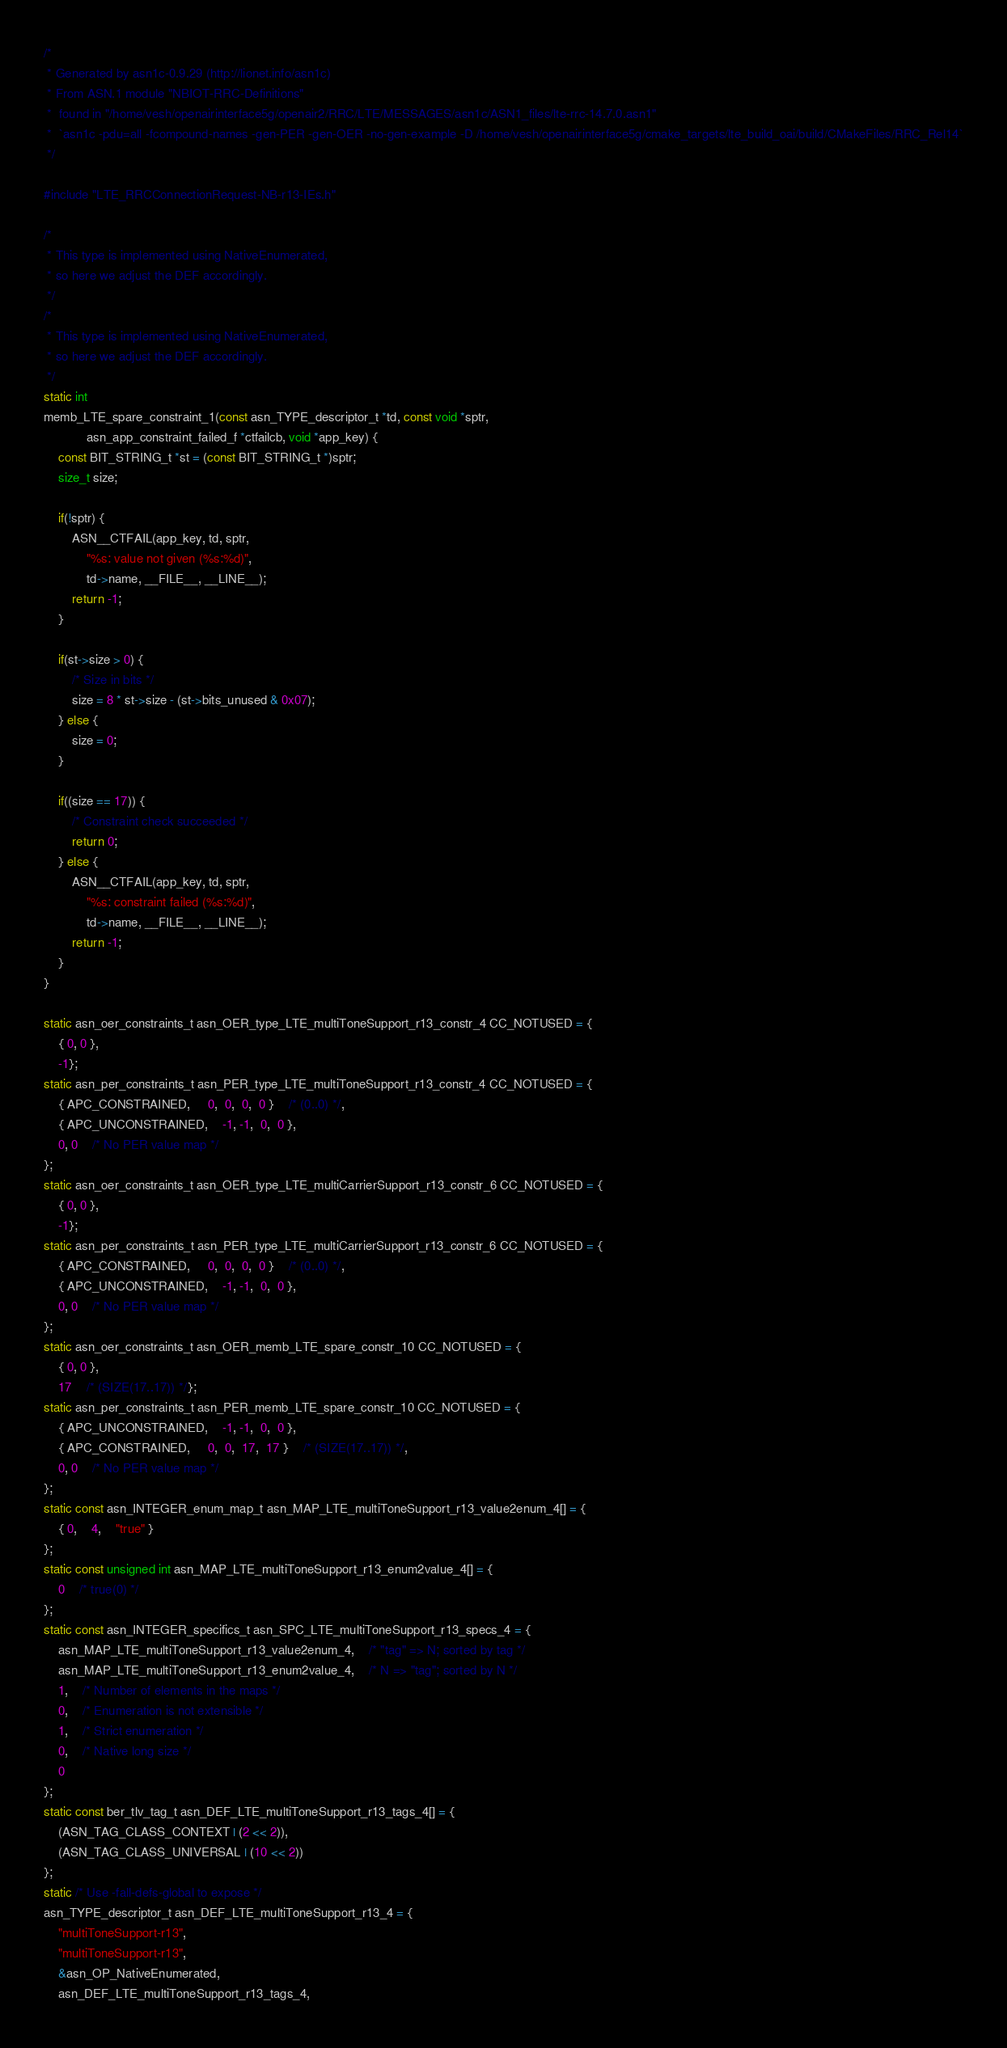Convert code to text. <code><loc_0><loc_0><loc_500><loc_500><_C_>/*
 * Generated by asn1c-0.9.29 (http://lionet.info/asn1c)
 * From ASN.1 module "NBIOT-RRC-Definitions"
 * 	found in "/home/vesh/openairinterface5g/openair2/RRC/LTE/MESSAGES/asn1c/ASN1_files/lte-rrc-14.7.0.asn1"
 * 	`asn1c -pdu=all -fcompound-names -gen-PER -gen-OER -no-gen-example -D /home/vesh/openairinterface5g/cmake_targets/lte_build_oai/build/CMakeFiles/RRC_Rel14`
 */

#include "LTE_RRCConnectionRequest-NB-r13-IEs.h"

/*
 * This type is implemented using NativeEnumerated,
 * so here we adjust the DEF accordingly.
 */
/*
 * This type is implemented using NativeEnumerated,
 * so here we adjust the DEF accordingly.
 */
static int
memb_LTE_spare_constraint_1(const asn_TYPE_descriptor_t *td, const void *sptr,
			asn_app_constraint_failed_f *ctfailcb, void *app_key) {
	const BIT_STRING_t *st = (const BIT_STRING_t *)sptr;
	size_t size;
	
	if(!sptr) {
		ASN__CTFAIL(app_key, td, sptr,
			"%s: value not given (%s:%d)",
			td->name, __FILE__, __LINE__);
		return -1;
	}
	
	if(st->size > 0) {
		/* Size in bits */
		size = 8 * st->size - (st->bits_unused & 0x07);
	} else {
		size = 0;
	}
	
	if((size == 17)) {
		/* Constraint check succeeded */
		return 0;
	} else {
		ASN__CTFAIL(app_key, td, sptr,
			"%s: constraint failed (%s:%d)",
			td->name, __FILE__, __LINE__);
		return -1;
	}
}

static asn_oer_constraints_t asn_OER_type_LTE_multiToneSupport_r13_constr_4 CC_NOTUSED = {
	{ 0, 0 },
	-1};
static asn_per_constraints_t asn_PER_type_LTE_multiToneSupport_r13_constr_4 CC_NOTUSED = {
	{ APC_CONSTRAINED,	 0,  0,  0,  0 }	/* (0..0) */,
	{ APC_UNCONSTRAINED,	-1, -1,  0,  0 },
	0, 0	/* No PER value map */
};
static asn_oer_constraints_t asn_OER_type_LTE_multiCarrierSupport_r13_constr_6 CC_NOTUSED = {
	{ 0, 0 },
	-1};
static asn_per_constraints_t asn_PER_type_LTE_multiCarrierSupport_r13_constr_6 CC_NOTUSED = {
	{ APC_CONSTRAINED,	 0,  0,  0,  0 }	/* (0..0) */,
	{ APC_UNCONSTRAINED,	-1, -1,  0,  0 },
	0, 0	/* No PER value map */
};
static asn_oer_constraints_t asn_OER_memb_LTE_spare_constr_10 CC_NOTUSED = {
	{ 0, 0 },
	17	/* (SIZE(17..17)) */};
static asn_per_constraints_t asn_PER_memb_LTE_spare_constr_10 CC_NOTUSED = {
	{ APC_UNCONSTRAINED,	-1, -1,  0,  0 },
	{ APC_CONSTRAINED,	 0,  0,  17,  17 }	/* (SIZE(17..17)) */,
	0, 0	/* No PER value map */
};
static const asn_INTEGER_enum_map_t asn_MAP_LTE_multiToneSupport_r13_value2enum_4[] = {
	{ 0,	4,	"true" }
};
static const unsigned int asn_MAP_LTE_multiToneSupport_r13_enum2value_4[] = {
	0	/* true(0) */
};
static const asn_INTEGER_specifics_t asn_SPC_LTE_multiToneSupport_r13_specs_4 = {
	asn_MAP_LTE_multiToneSupport_r13_value2enum_4,	/* "tag" => N; sorted by tag */
	asn_MAP_LTE_multiToneSupport_r13_enum2value_4,	/* N => "tag"; sorted by N */
	1,	/* Number of elements in the maps */
	0,	/* Enumeration is not extensible */
	1,	/* Strict enumeration */
	0,	/* Native long size */
	0
};
static const ber_tlv_tag_t asn_DEF_LTE_multiToneSupport_r13_tags_4[] = {
	(ASN_TAG_CLASS_CONTEXT | (2 << 2)),
	(ASN_TAG_CLASS_UNIVERSAL | (10 << 2))
};
static /* Use -fall-defs-global to expose */
asn_TYPE_descriptor_t asn_DEF_LTE_multiToneSupport_r13_4 = {
	"multiToneSupport-r13",
	"multiToneSupport-r13",
	&asn_OP_NativeEnumerated,
	asn_DEF_LTE_multiToneSupport_r13_tags_4,</code> 